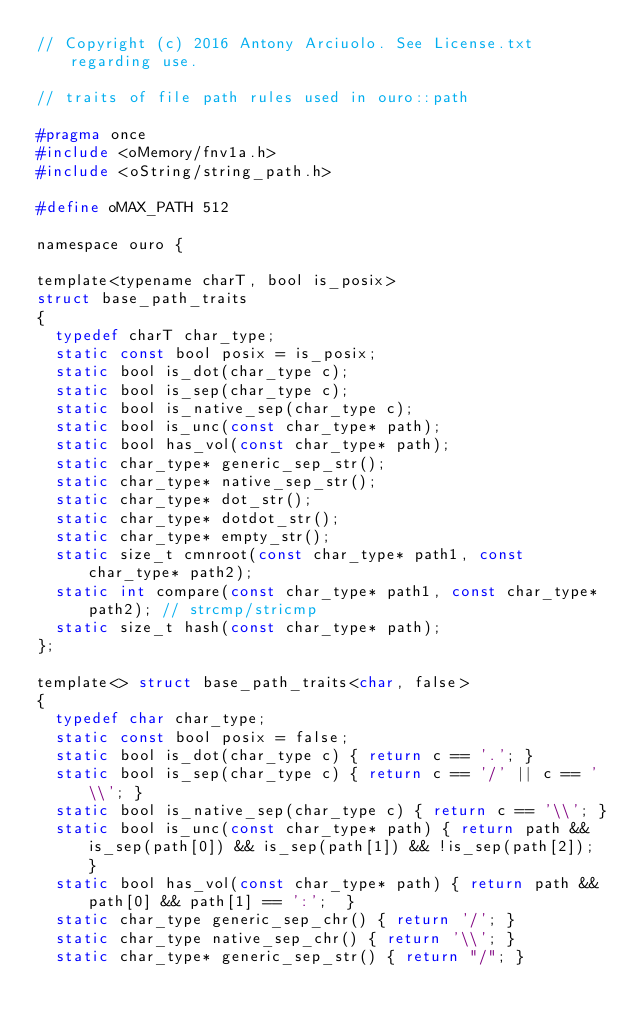<code> <loc_0><loc_0><loc_500><loc_500><_C_>// Copyright (c) 2016 Antony Arciuolo. See License.txt regarding use.

// traits of file path rules used in ouro::path

#pragma once
#include <oMemory/fnv1a.h>
#include <oString/string_path.h>

#define oMAX_PATH 512

namespace ouro {

template<typename charT, bool is_posix>
struct base_path_traits
{
	typedef charT char_type;
	static const bool posix = is_posix;
	static bool is_dot(char_type c);
	static bool is_sep(char_type c);
	static bool is_native_sep(char_type c);
	static bool is_unc(const char_type* path);
	static bool has_vol(const char_type* path);
	static char_type* generic_sep_str();
	static char_type* native_sep_str();
	static char_type* dot_str();
	static char_type* dotdot_str();
	static char_type* empty_str();
	static size_t cmnroot(const char_type* path1, const char_type* path2);
	static int compare(const char_type* path1, const char_type* path2); // strcmp/stricmp
	static size_t hash(const char_type* path);
};

template<> struct base_path_traits<char, false>
{
	typedef char char_type;
	static const bool posix = false;
	static bool is_dot(char_type c) { return c == '.'; }
	static bool is_sep(char_type c) { return c == '/' || c == '\\'; }
	static bool is_native_sep(char_type c) { return c == '\\'; }
	static bool is_unc(const char_type* path) { return path && is_sep(path[0]) && is_sep(path[1]) && !is_sep(path[2]); }
	static bool has_vol(const char_type* path) { return path && path[0] && path[1] == ':';  }
	static char_type generic_sep_chr() { return '/'; }
	static char_type native_sep_chr() { return '\\'; }
	static char_type* generic_sep_str() { return "/"; }</code> 